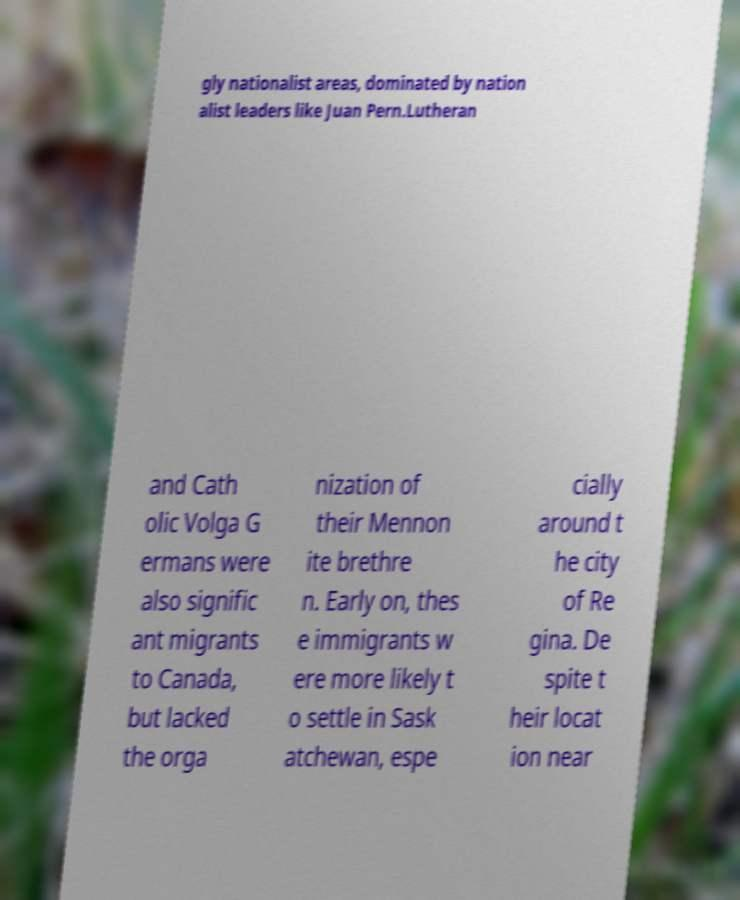Please read and relay the text visible in this image. What does it say? gly nationalist areas, dominated by nation alist leaders like Juan Pern.Lutheran and Cath olic Volga G ermans were also signific ant migrants to Canada, but lacked the orga nization of their Mennon ite brethre n. Early on, thes e immigrants w ere more likely t o settle in Sask atchewan, espe cially around t he city of Re gina. De spite t heir locat ion near 